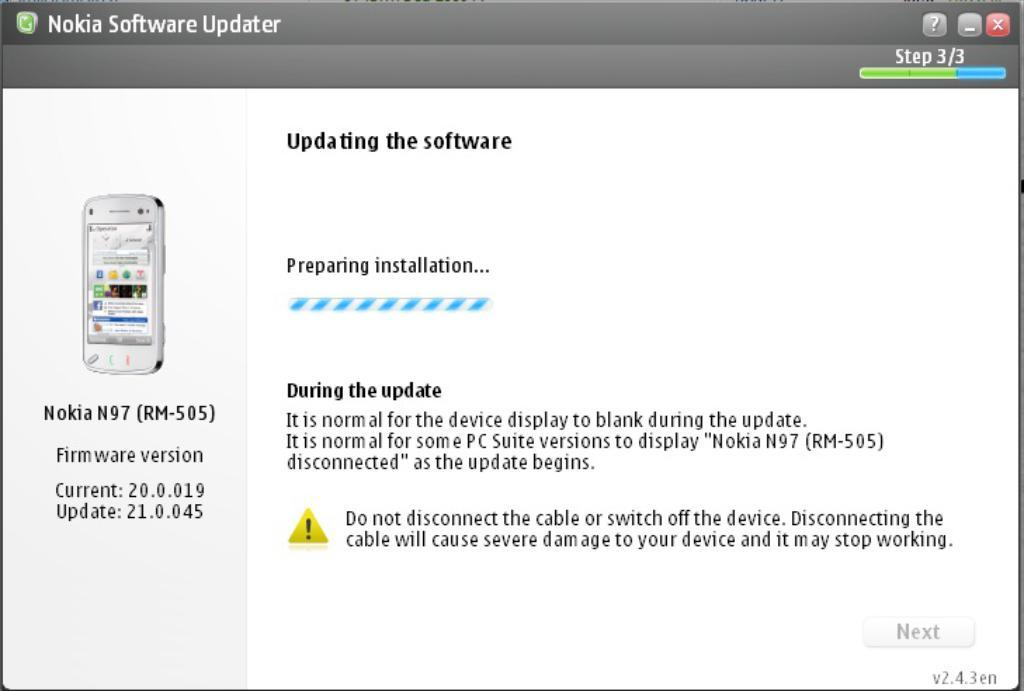What can be found in the image besides the mobile? There is text in the image. Can you describe the image of the mobile? The image features a mobile, which is a type of hanging decoration with various objects attached to it. What color is the ink used for the text in the image? There is no mention of ink in the provided facts, as the text's color is not specified. Can you hear the mobile crying in the image? The image is a visual representation, and there is no sound or indication of crying associated with the mobile. 